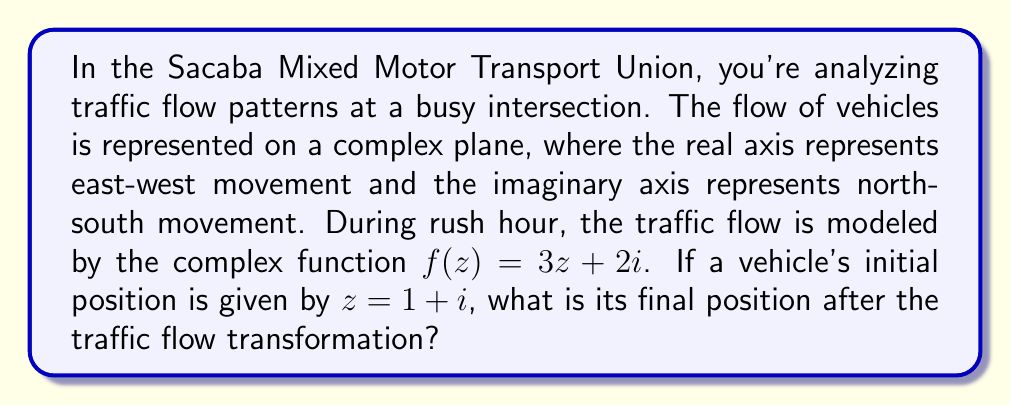Teach me how to tackle this problem. Let's approach this step-by-step:

1) We are given the complex function $f(z) = 3z + 2i$ which represents the traffic flow transformation.

2) The initial position of the vehicle is $z = 1 + i$.

3) To find the final position, we need to apply the function $f$ to the initial position $z$:

   $f(z) = 3z + 2i$
   $f(1 + i) = 3(1 + i) + 2i$

4) Let's expand this:
   $3(1 + i) + 2i = 3 + 3i + 2i$

5) Combining like terms:
   $3 + 3i + 2i = 3 + 5i$

6) Therefore, the final position of the vehicle after the traffic flow transformation is $3 + 5i$.

This means the vehicle has moved 3 units east and 5 units north from its original position.
Answer: $3 + 5i$ 